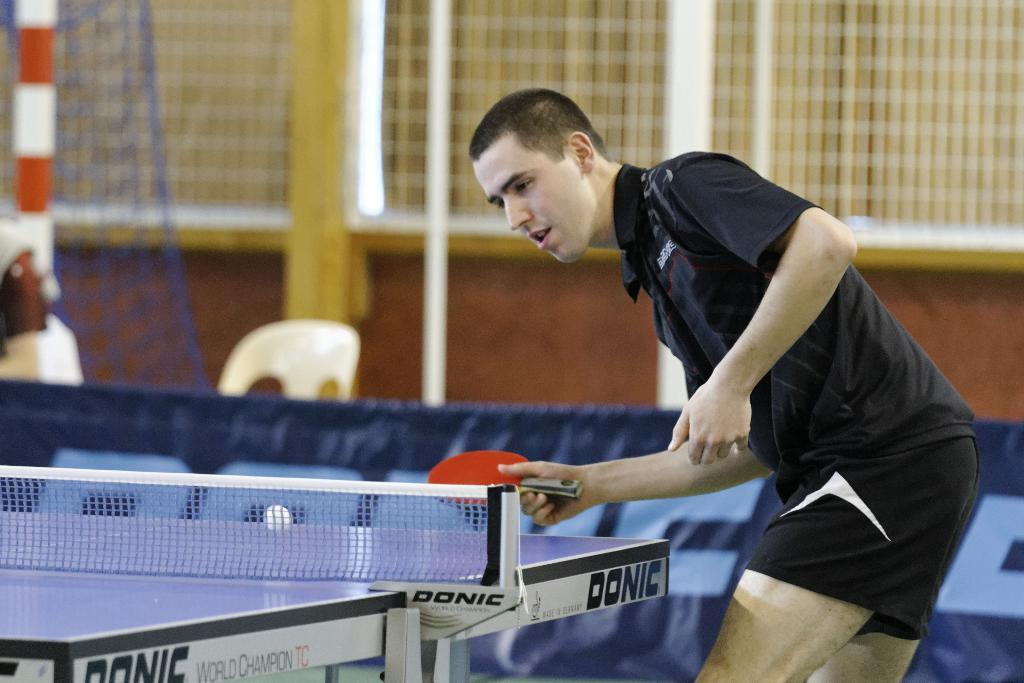What is the main subject of the image? There is a person in the image. What is the person wearing? The person is wearing a black color T-shirt. What activity is the person engaged in? The person is playing table tennis. Can you see any punishment being given to the person in the image? There is no indication of punishment in the image; the person is playing table tennis. Is there a cobweb visible in the image? There is no mention of a cobweb in the provided facts, so we cannot determine if one is present in the image. 